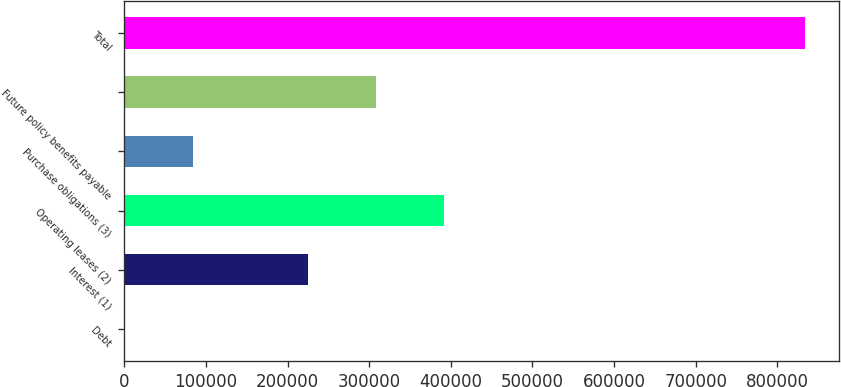<chart> <loc_0><loc_0><loc_500><loc_500><bar_chart><fcel>Debt<fcel>Interest (1)<fcel>Operating leases (2)<fcel>Purchase obligations (3)<fcel>Future policy benefits payable<fcel>Total<nl><fcel>333<fcel>225342<fcel>392056<fcel>83690.1<fcel>308699<fcel>833904<nl></chart> 